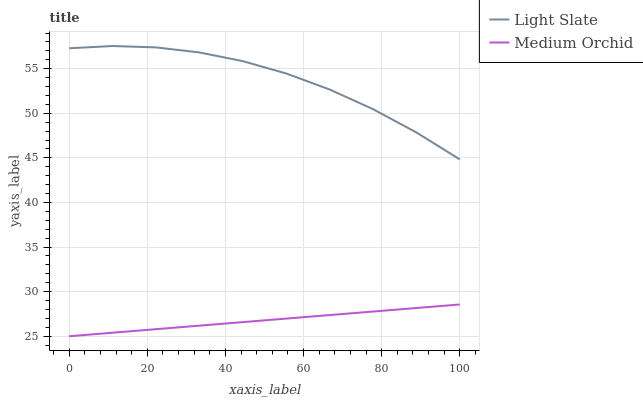Does Medium Orchid have the minimum area under the curve?
Answer yes or no. Yes. Does Light Slate have the maximum area under the curve?
Answer yes or no. Yes. Does Medium Orchid have the maximum area under the curve?
Answer yes or no. No. Is Medium Orchid the smoothest?
Answer yes or no. Yes. Is Light Slate the roughest?
Answer yes or no. Yes. Is Medium Orchid the roughest?
Answer yes or no. No. Does Light Slate have the highest value?
Answer yes or no. Yes. Does Medium Orchid have the highest value?
Answer yes or no. No. Is Medium Orchid less than Light Slate?
Answer yes or no. Yes. Is Light Slate greater than Medium Orchid?
Answer yes or no. Yes. Does Medium Orchid intersect Light Slate?
Answer yes or no. No. 